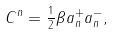<formula> <loc_0><loc_0><loc_500><loc_500>C ^ { n } = \frac { _ { 1 } } { ^ { 2 } } \beta a _ { n } ^ { + } a _ { n } ^ { - } ,</formula> 